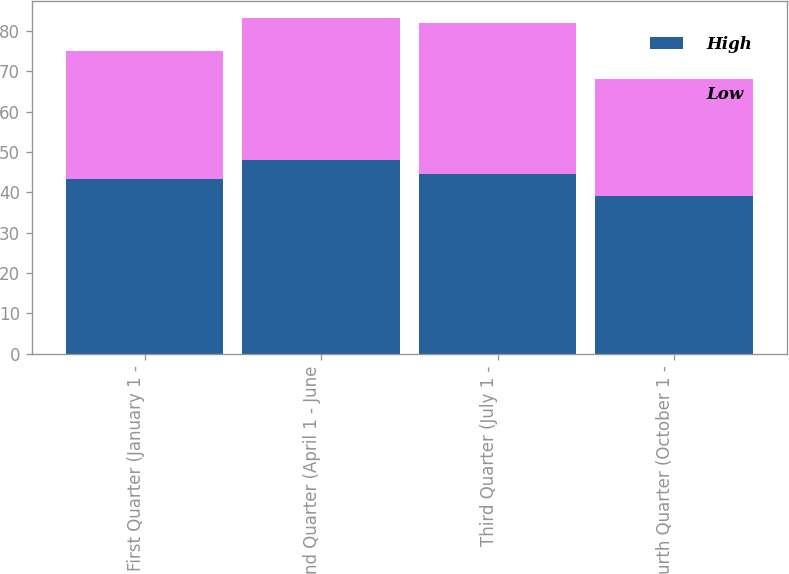Convert chart. <chart><loc_0><loc_0><loc_500><loc_500><stacked_bar_chart><ecel><fcel>First Quarter (January 1 -<fcel>Second Quarter (April 1 - June<fcel>Third Quarter (July 1 -<fcel>Fourth Quarter (October 1 -<nl><fcel>High<fcel>43.42<fcel>47.95<fcel>44.68<fcel>39.2<nl><fcel>Low<fcel>31.62<fcel>35.35<fcel>37.23<fcel>29<nl></chart> 